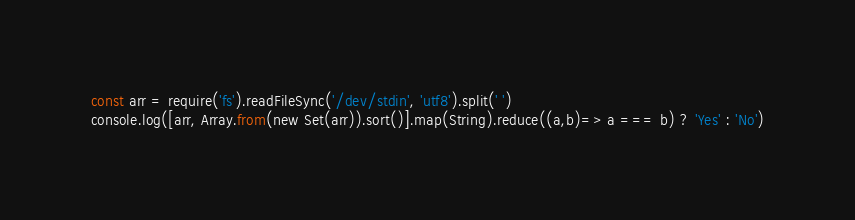Convert code to text. <code><loc_0><loc_0><loc_500><loc_500><_JavaScript_>const arr = require('fs').readFileSync('/dev/stdin', 'utf8').split(' ')
console.log([arr, Array.from(new Set(arr)).sort()].map(String).reduce((a,b)=> a === b) ? 'Yes' : 'No')
</code> 